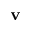<formula> <loc_0><loc_0><loc_500><loc_500>v</formula> 